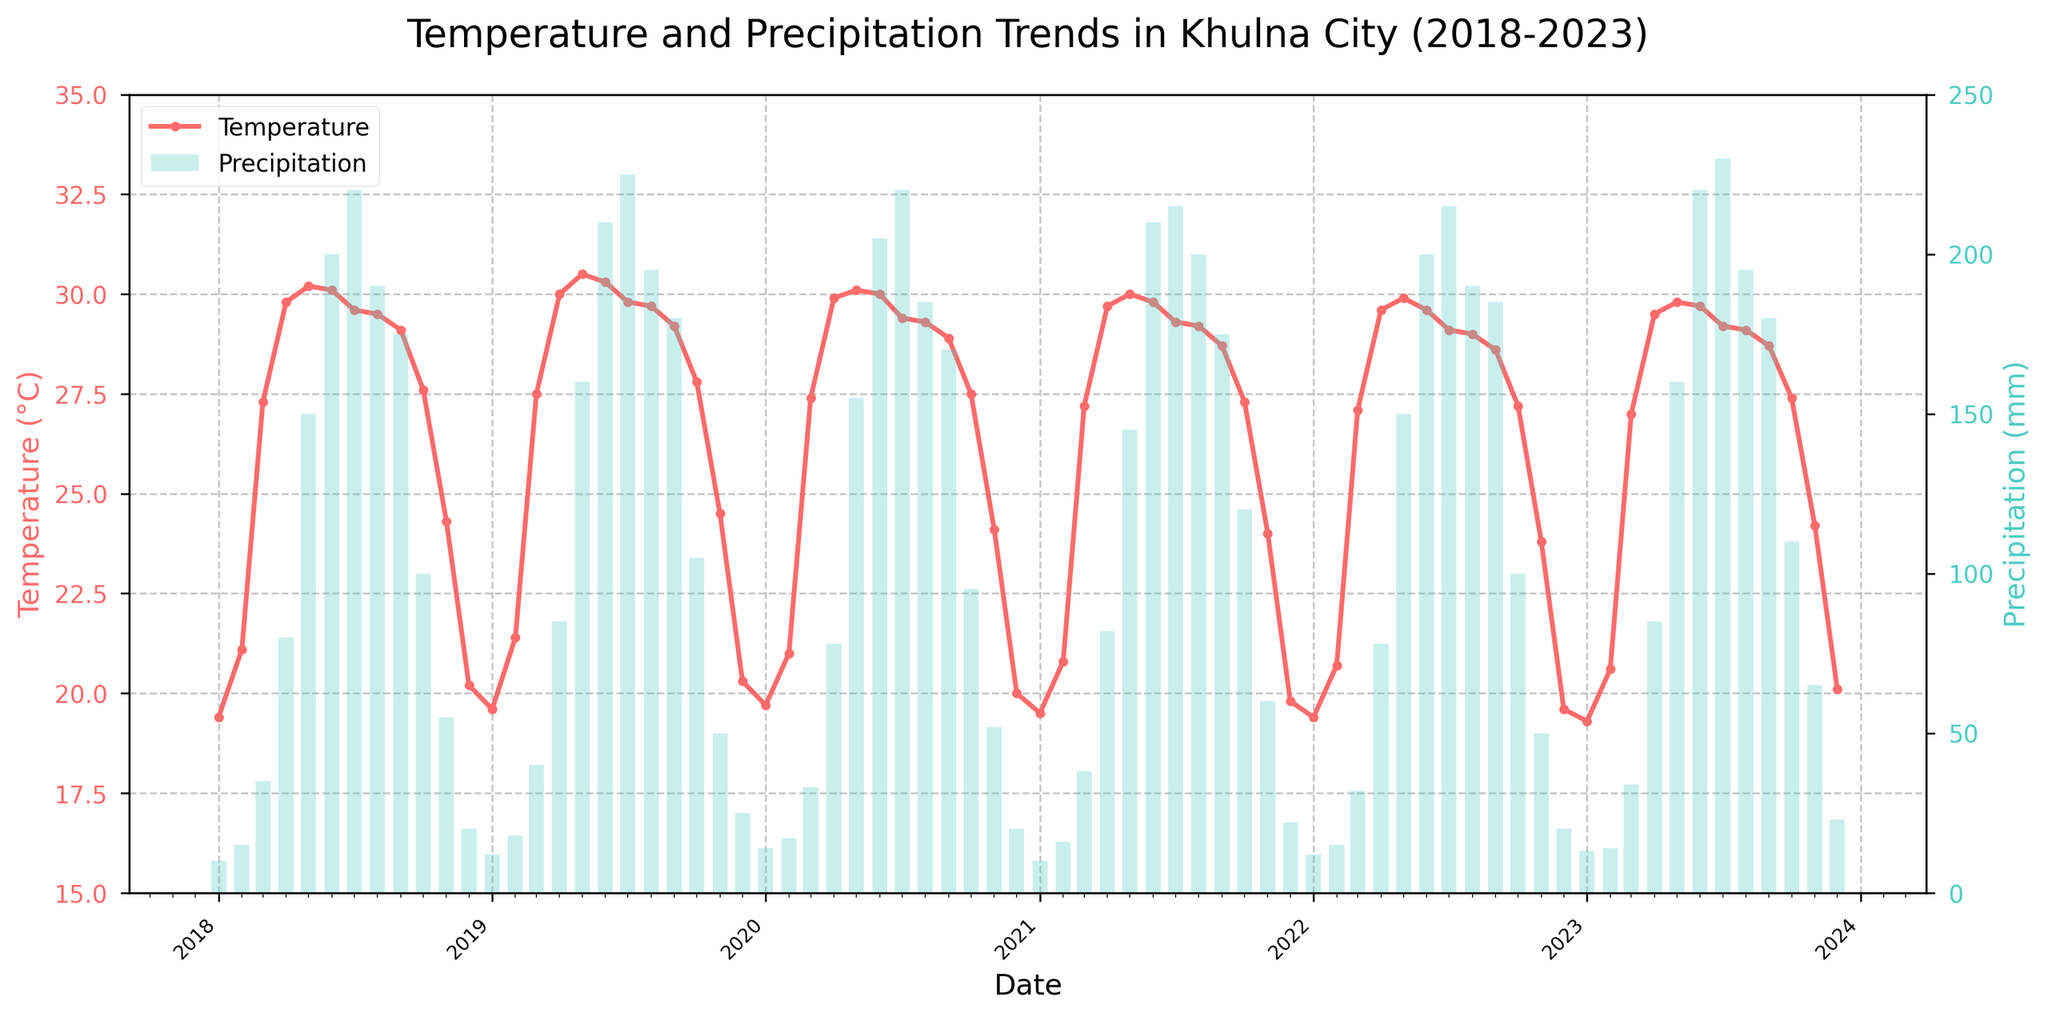What is the title of the figure? The title is typically placed at the top of the figure and describes what the plot is about. In this case, it should indicate the location and the time frame of the data displayed.
Answer: Temperature and Precipitation Trends in Khulna City (2018-2023) What colors represent the temperature and precipitation trends on the plot? On the plot, colors are used to distinguish different types of data. Here, the temperature trend is typically shown with a color that stands out against the data bars of the precipitation. Look for lines and bars to identify this.
Answer: The temperature is represented by red lines, and the precipitation is represented by cyan bars What is the range of the temperature (in °C) over the past five years? The range can be found by looking at the y-axis on the left side, which indicates temperature, and noting the minimum and maximum values within the time frame shown.
Answer: The temperature ranges from 15°C to 35°C Which month and year had the highest recorded precipitation? Scan the height of the blue bars representing precipitation to find the tallest one, which corresponds to the highest value. The x-axis will show which month and year it is.
Answer: July 2023 What is the average precipitation for the month of June across all five years? To find the average, identify the precipitation values for June in each year, sum them up, and divide by the number of years (5).
Answer: (200 + 210 + 205 + 210 + 200 + 220)/6 = 207.5 mm How does the temperature trend in July 2023 compare to July 2018? Look at the temperature plot line for the month of July in both 2018 and 2023 to compare the values. You can find these values by checking the y-axis next to the plot points.
Answer: The temperature in July 2023 (29.2°C) is slightly lower than in July 2018 (29.6°C) During which months and years do the highest and lowest average temperatures occur? Scan the highest and lowest points of the temperature line plot over the full time span. Check the corresponding months and years for these extremes.
Answer: Highest: May 2019 at 30.5°C; Lowest: January 2023 at 19.3°C Is there a noticeable seasonal pattern in the precipitation data? Observe the bar heights corresponding with each month across different years. Look for a recurring high or low pattern across the same months over different years.
Answer: Yes, higher precipitation is observed consistently from May to September What is the trend observed in average temperatures from 2018 to 2023? Look for the overall direction of the temperature line plot from the beginning to the end of the period. Check if it is increasing, decreasing, or stable.
Answer: The trend shows a slight decrease in average temperature How do the precipitation values in November 2023 compare to November 2018? Check the height of the bars for November in both years and compare according to the scale on the y-axis to the right of the chart.
Answer: November 2023 (65 mm) had higher precipitation than November 2018 (55 mm) 